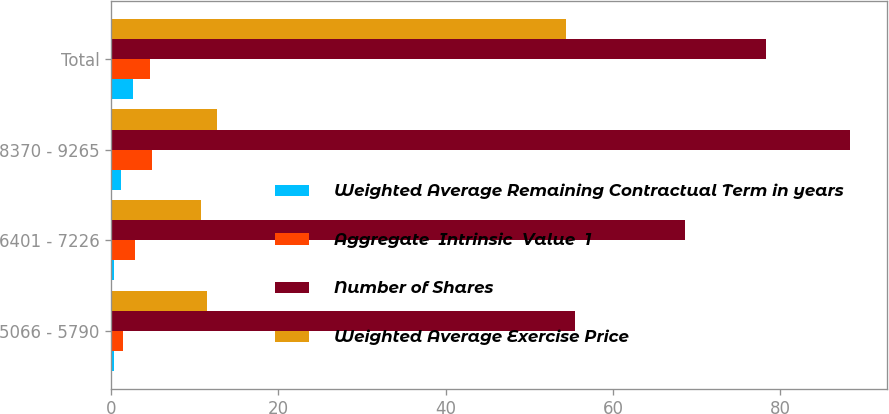<chart> <loc_0><loc_0><loc_500><loc_500><stacked_bar_chart><ecel><fcel>5066 - 5790<fcel>6401 - 7226<fcel>8370 - 9265<fcel>Total<nl><fcel>Weighted Average Remaining Contractual Term in years<fcel>0.3<fcel>0.3<fcel>1.2<fcel>2.6<nl><fcel>Aggregate  Intrinsic  Value  1<fcel>1.4<fcel>2.9<fcel>4.9<fcel>4.7<nl><fcel>Number of Shares<fcel>55.47<fcel>68.59<fcel>88.28<fcel>78.25<nl><fcel>Weighted Average Exercise Price<fcel>11.5<fcel>10.7<fcel>12.6<fcel>54.4<nl></chart> 